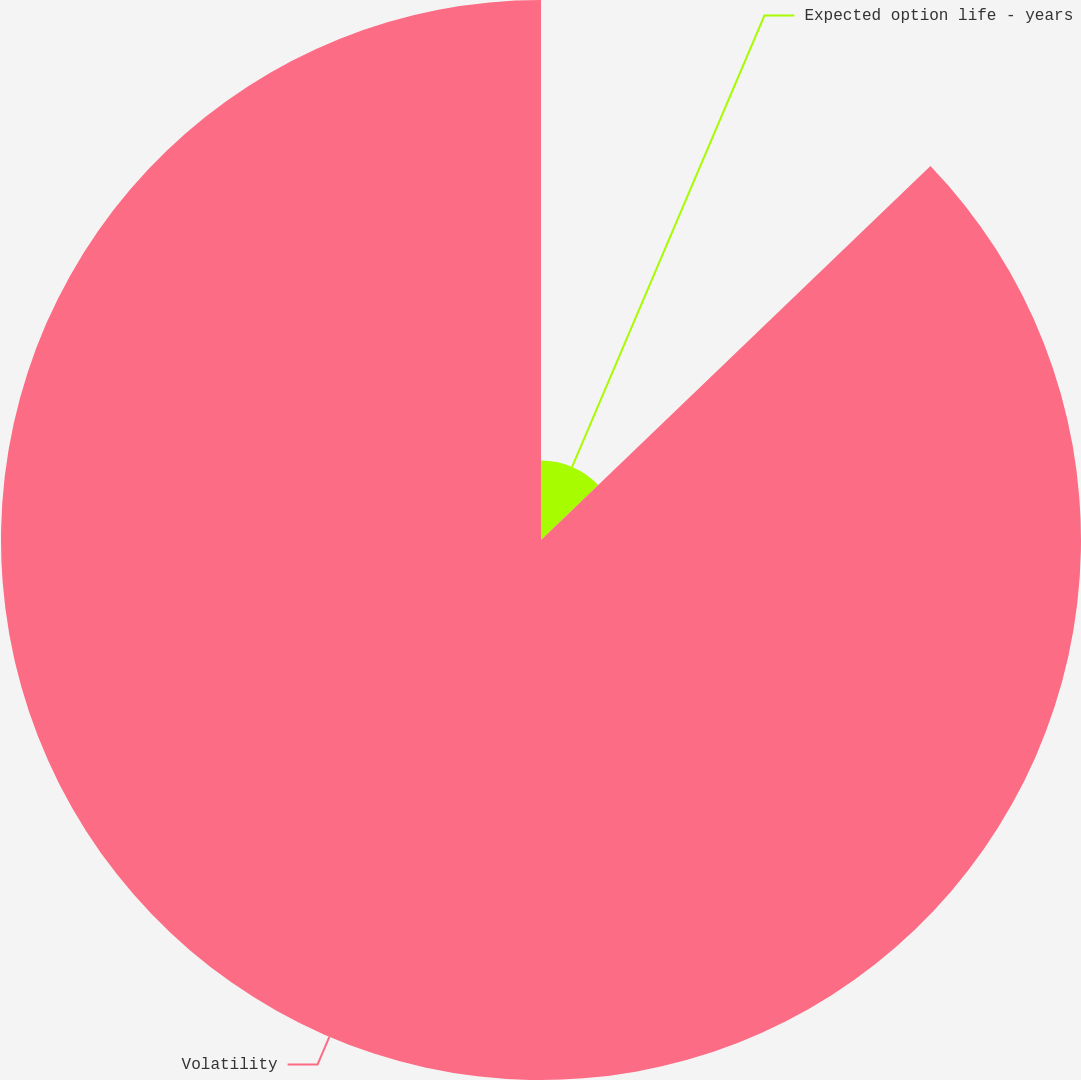Convert chart. <chart><loc_0><loc_0><loc_500><loc_500><pie_chart><fcel>Expected option life - years<fcel>Volatility<nl><fcel>12.82%<fcel>87.18%<nl></chart> 